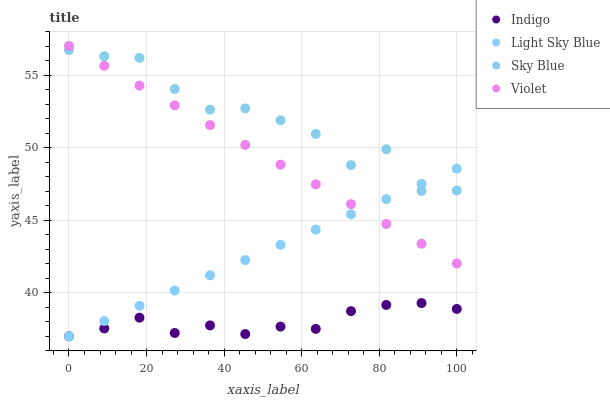Does Indigo have the minimum area under the curve?
Answer yes or no. Yes. Does Sky Blue have the maximum area under the curve?
Answer yes or no. Yes. Does Light Sky Blue have the minimum area under the curve?
Answer yes or no. No. Does Light Sky Blue have the maximum area under the curve?
Answer yes or no. No. Is Violet the smoothest?
Answer yes or no. Yes. Is Sky Blue the roughest?
Answer yes or no. Yes. Is Light Sky Blue the smoothest?
Answer yes or no. No. Is Light Sky Blue the roughest?
Answer yes or no. No. Does Light Sky Blue have the lowest value?
Answer yes or no. Yes. Does Violet have the lowest value?
Answer yes or no. No. Does Violet have the highest value?
Answer yes or no. Yes. Does Light Sky Blue have the highest value?
Answer yes or no. No. Is Indigo less than Violet?
Answer yes or no. Yes. Is Sky Blue greater than Indigo?
Answer yes or no. Yes. Does Sky Blue intersect Light Sky Blue?
Answer yes or no. Yes. Is Sky Blue less than Light Sky Blue?
Answer yes or no. No. Is Sky Blue greater than Light Sky Blue?
Answer yes or no. No. Does Indigo intersect Violet?
Answer yes or no. No. 